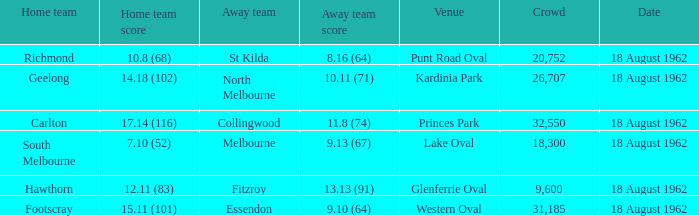Which team was playing away when the home team achieved a score of 10.8 (68)? St Kilda. 